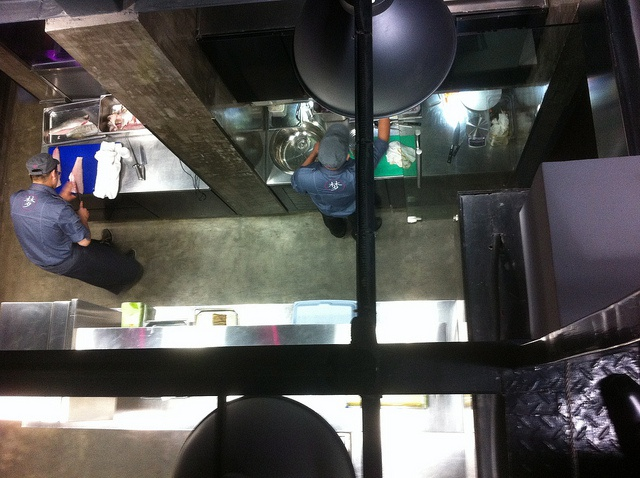Describe the objects in this image and their specific colors. I can see people in black and gray tones, people in black, gray, blue, and darkblue tones, sink in black, gray, and darkgray tones, bowl in black, gray, and darkgray tones, and knife in black, gray, and purple tones in this image. 